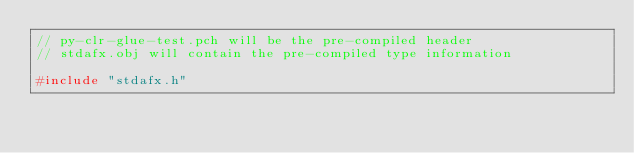<code> <loc_0><loc_0><loc_500><loc_500><_C++_>// py-clr-glue-test.pch will be the pre-compiled header
// stdafx.obj will contain the pre-compiled type information

#include "stdafx.h"
</code> 